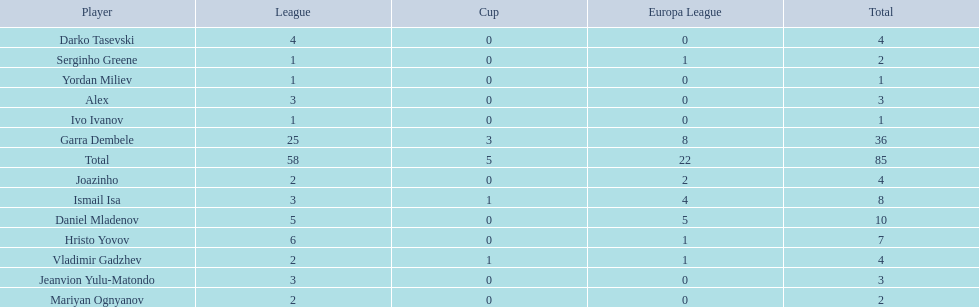Can you parse all the data within this table? {'header': ['Player', 'League', 'Cup', 'Europa League', 'Total'], 'rows': [['Darko Tasevski', '4', '0', '0', '4'], ['Serginho Greene', '1', '0', '1', '2'], ['Yordan Miliev', '1', '0', '0', '1'], ['Alex', '3', '0', '0', '3'], ['Ivo Ivanov', '1', '0', '0', '1'], ['Garra Dembele', '25', '3', '8', '36'], ['Total', '58', '5', '22', '85'], ['Joazinho', '2', '0', '2', '4'], ['Ismail Isa', '3', '1', '4', '8'], ['Daniel Mladenov', '5', '0', '5', '10'], ['Hristo Yovov', '6', '0', '1', '7'], ['Vladimir Gadzhev', '2', '1', '1', '4'], ['Jeanvion Yulu-Matondo', '3', '0', '0', '3'], ['Mariyan Ognyanov', '2', '0', '0', '2']]} What players did not score in all 3 competitions? Daniel Mladenov, Hristo Yovov, Joazinho, Darko Tasevski, Alex, Jeanvion Yulu-Matondo, Mariyan Ognyanov, Serginho Greene, Yordan Miliev, Ivo Ivanov. Which of those did not have total more then 5? Darko Tasevski, Alex, Jeanvion Yulu-Matondo, Mariyan Ognyanov, Serginho Greene, Yordan Miliev, Ivo Ivanov. Which ones scored more then 1 total? Darko Tasevski, Alex, Jeanvion Yulu-Matondo, Mariyan Ognyanov. Which of these player had the lease league points? Mariyan Ognyanov. 